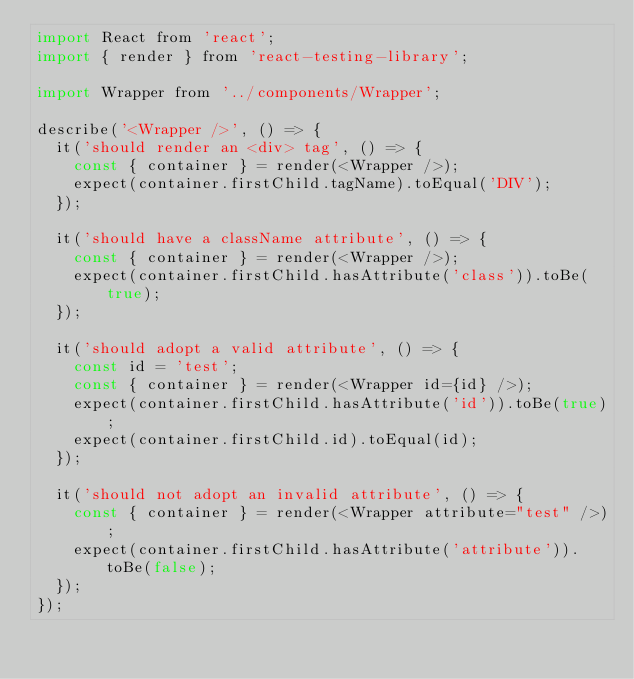Convert code to text. <code><loc_0><loc_0><loc_500><loc_500><_JavaScript_>import React from 'react';
import { render } from 'react-testing-library';

import Wrapper from '../components/Wrapper';

describe('<Wrapper />', () => {
  it('should render an <div> tag', () => {
    const { container } = render(<Wrapper />);
    expect(container.firstChild.tagName).toEqual('DIV');
  });

  it('should have a className attribute', () => {
    const { container } = render(<Wrapper />);
    expect(container.firstChild.hasAttribute('class')).toBe(true);
  });

  it('should adopt a valid attribute', () => {
    const id = 'test';
    const { container } = render(<Wrapper id={id} />);
    expect(container.firstChild.hasAttribute('id')).toBe(true);
    expect(container.firstChild.id).toEqual(id);
  });

  it('should not adopt an invalid attribute', () => {
    const { container } = render(<Wrapper attribute="test" />);
    expect(container.firstChild.hasAttribute('attribute')).toBe(false);
  });
});
</code> 